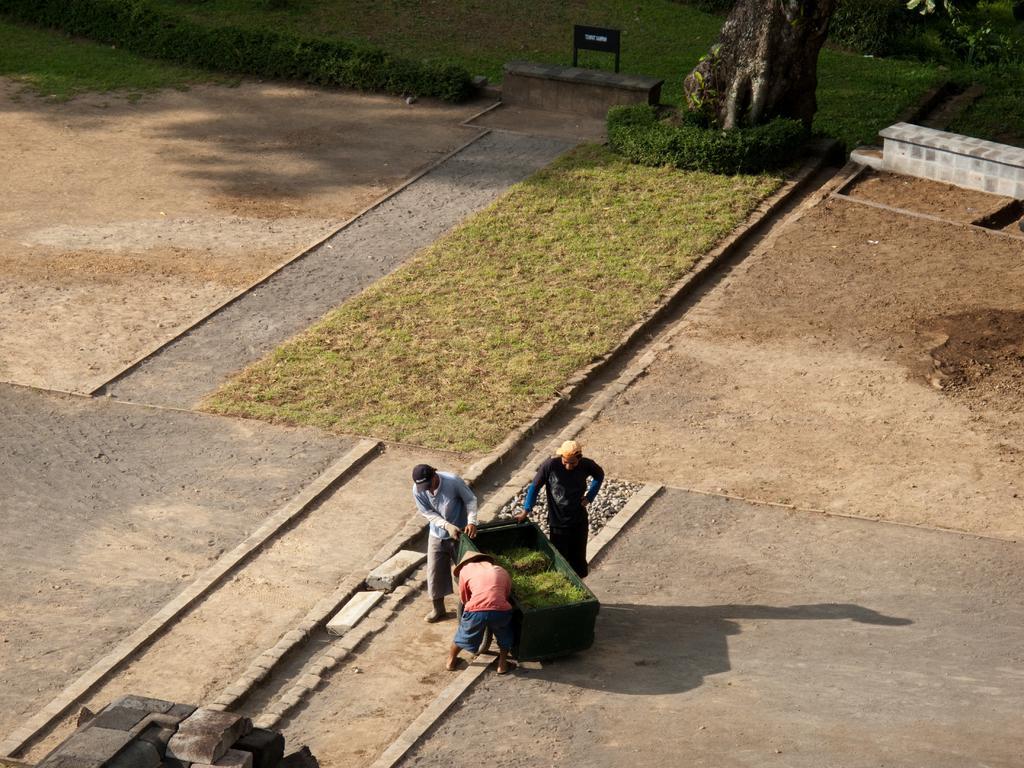Can you describe this image briefly? In this image we can see few people holding the object, around them there are trees, plants, ground, and a board. 